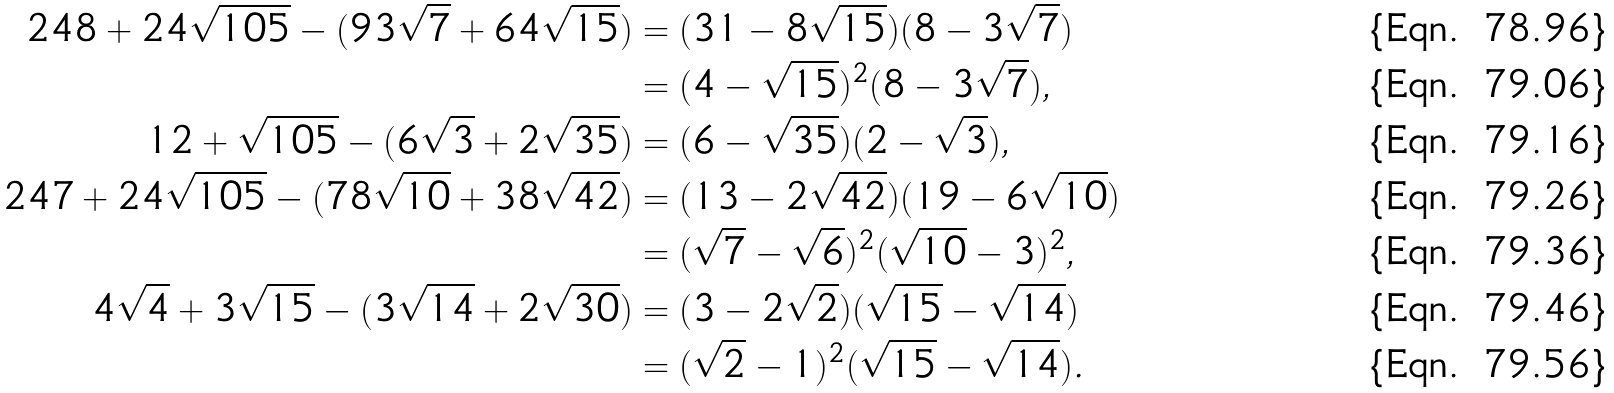Convert formula to latex. <formula><loc_0><loc_0><loc_500><loc_500>2 4 8 + 2 4 \sqrt { 1 0 5 } - ( 9 3 \sqrt { 7 } + 6 4 \sqrt { 1 5 } ) & = ( 3 1 - 8 \sqrt { 1 5 } ) ( 8 - 3 \sqrt { 7 } ) \\ & = ( 4 - \sqrt { 1 5 } ) ^ { 2 } ( 8 - 3 \sqrt { 7 } ) , \\ 1 2 + \sqrt { 1 0 5 } - ( 6 \sqrt { 3 } + 2 \sqrt { 3 5 } ) & = ( 6 - \sqrt { 3 5 } ) ( 2 - \sqrt { 3 } ) , \\ 2 4 7 + 2 4 \sqrt { 1 0 5 } - ( 7 8 \sqrt { 1 0 } + 3 8 \sqrt { 4 2 } ) & = ( 1 3 - 2 \sqrt { 4 2 } ) ( 1 9 - 6 \sqrt { 1 0 } ) \\ & = ( \sqrt { 7 } - \sqrt { 6 } ) ^ { 2 } ( \sqrt { 1 0 } - 3 ) ^ { 2 } , \\ 4 \sqrt { 4 } + 3 \sqrt { 1 5 } - ( 3 \sqrt { 1 4 } + 2 \sqrt { 3 0 } ) & = ( 3 - 2 \sqrt { 2 } ) ( \sqrt { 1 5 } - \sqrt { 1 4 } ) \\ & = ( \sqrt { 2 } - 1 ) ^ { 2 } ( \sqrt { 1 5 } - \sqrt { 1 4 } ) .</formula> 